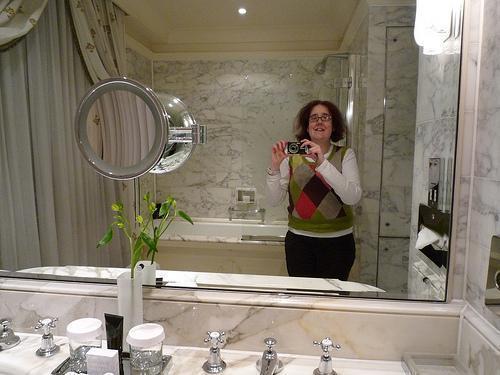How many people are there?
Give a very brief answer. 1. How many glasses are on the counter?
Give a very brief answer. 2. 